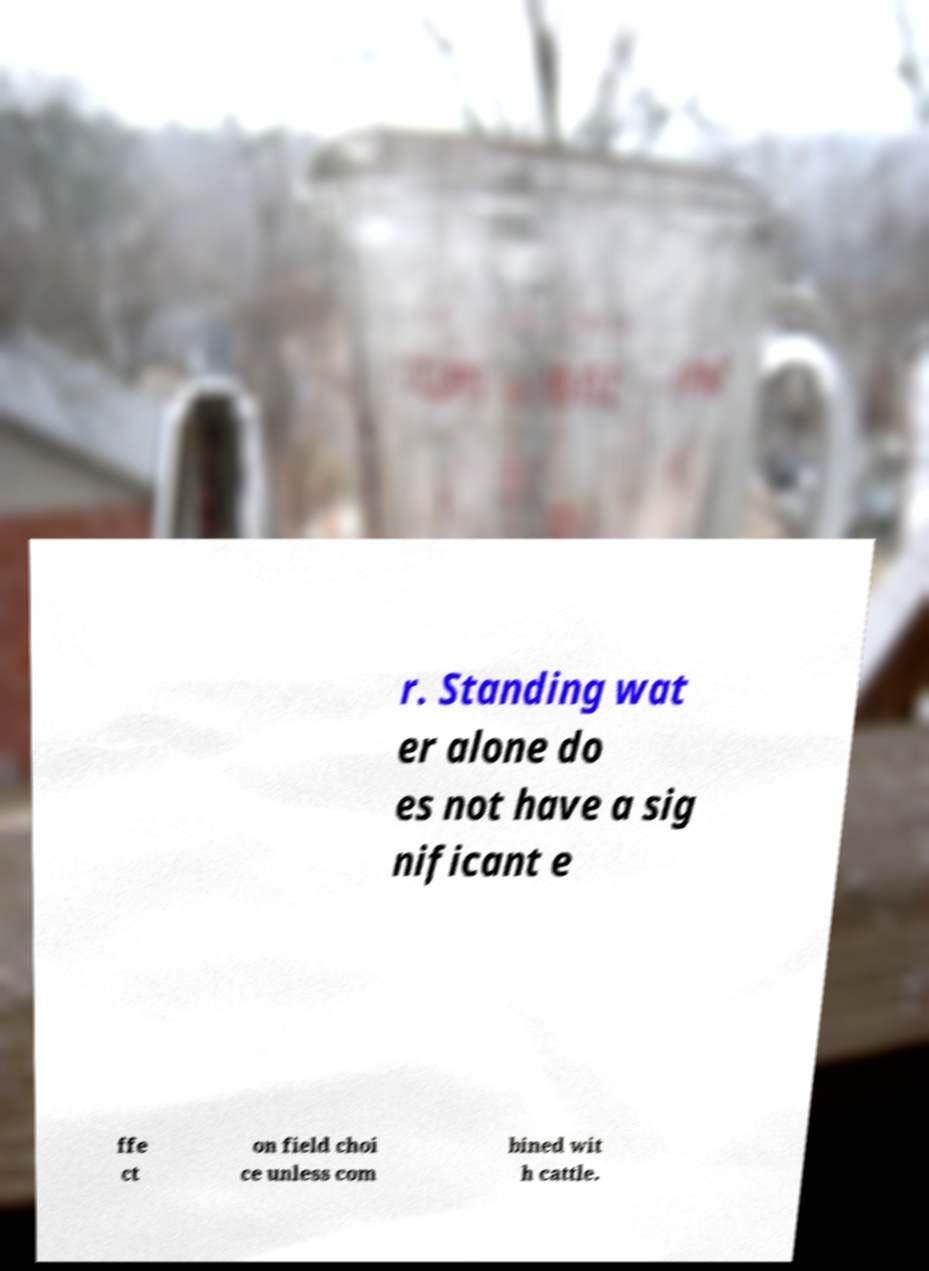Can you read and provide the text displayed in the image?This photo seems to have some interesting text. Can you extract and type it out for me? r. Standing wat er alone do es not have a sig nificant e ffe ct on field choi ce unless com bined wit h cattle. 